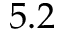<formula> <loc_0><loc_0><loc_500><loc_500>5 . 2</formula> 